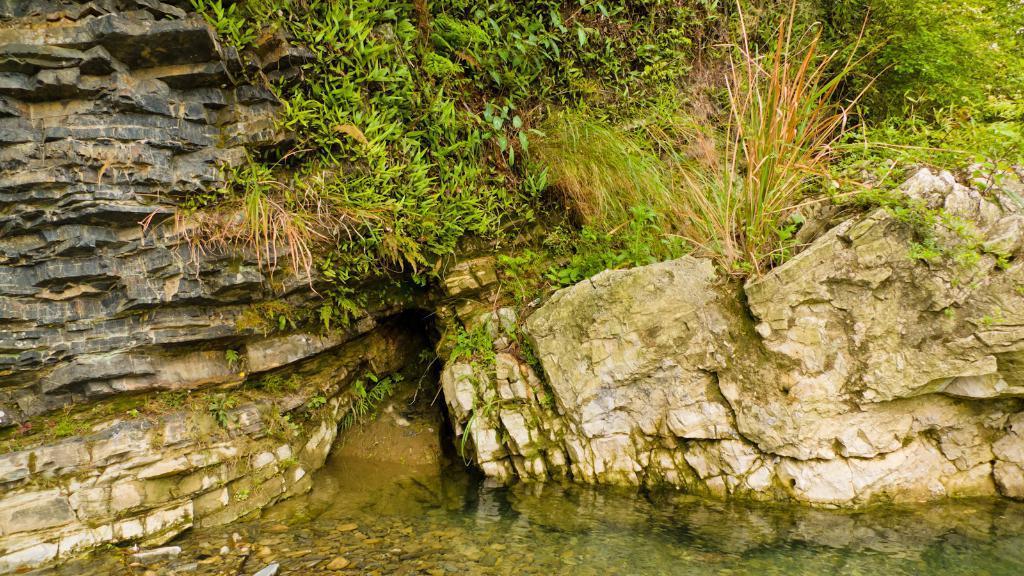In one or two sentences, can you explain what this image depicts? In this picture there are plants and there are rocks. At the bottom there is water and there are stones under the water. 